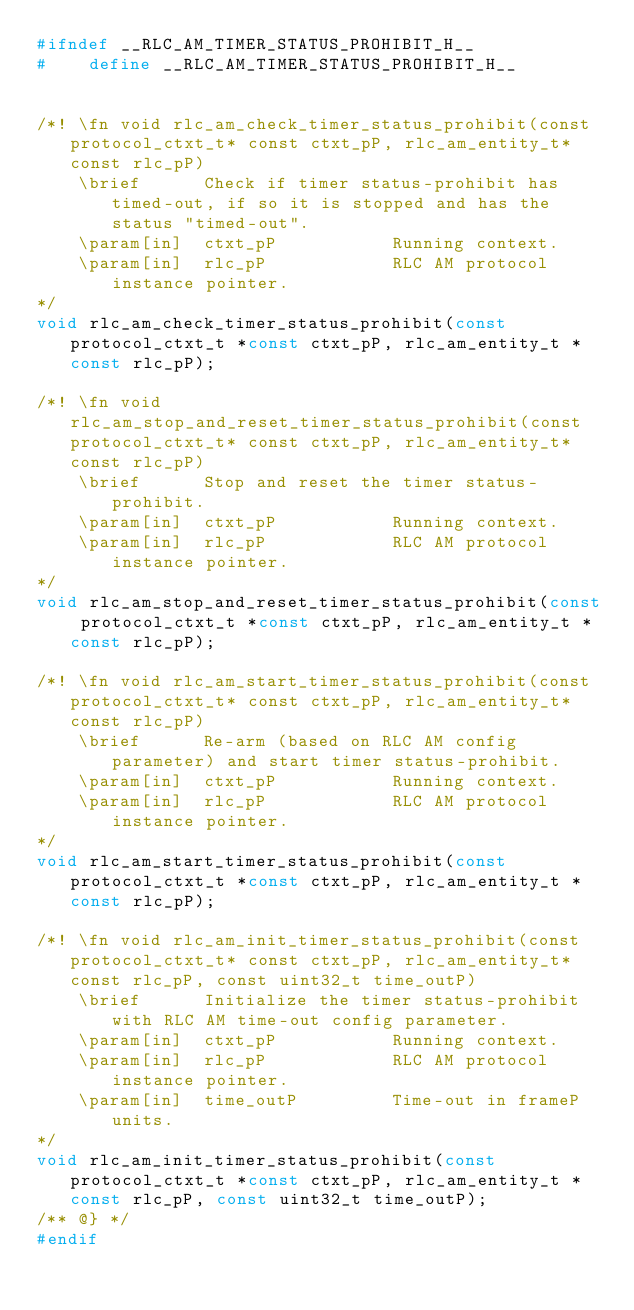Convert code to text. <code><loc_0><loc_0><loc_500><loc_500><_C_>#ifndef __RLC_AM_TIMER_STATUS_PROHIBIT_H__
#    define __RLC_AM_TIMER_STATUS_PROHIBIT_H__


/*! \fn void rlc_am_check_timer_status_prohibit(const protocol_ctxt_t* const ctxt_pP, rlc_am_entity_t* const rlc_pP)
    \brief      Check if timer status-prohibit has timed-out, if so it is stopped and has the status "timed-out".
    \param[in]  ctxt_pP           Running context.
    \param[in]  rlc_pP            RLC AM protocol instance pointer.
*/
void rlc_am_check_timer_status_prohibit(const protocol_ctxt_t *const ctxt_pP, rlc_am_entity_t *const rlc_pP);

/*! \fn void rlc_am_stop_and_reset_timer_status_prohibit(const protocol_ctxt_t* const ctxt_pP, rlc_am_entity_t* const rlc_pP)
    \brief      Stop and reset the timer status-prohibit.
    \param[in]  ctxt_pP           Running context.
    \param[in]  rlc_pP            RLC AM protocol instance pointer.
*/
void rlc_am_stop_and_reset_timer_status_prohibit(const protocol_ctxt_t *const ctxt_pP, rlc_am_entity_t *const rlc_pP);

/*! \fn void rlc_am_start_timer_status_prohibit(const protocol_ctxt_t* const ctxt_pP, rlc_am_entity_t* const rlc_pP)
    \brief      Re-arm (based on RLC AM config parameter) and start timer status-prohibit.
    \param[in]  ctxt_pP           Running context.
    \param[in]  rlc_pP            RLC AM protocol instance pointer.
*/
void rlc_am_start_timer_status_prohibit(const protocol_ctxt_t *const ctxt_pP, rlc_am_entity_t *const rlc_pP);

/*! \fn void rlc_am_init_timer_status_prohibit(const protocol_ctxt_t* const ctxt_pP, rlc_am_entity_t* const rlc_pP, const uint32_t time_outP)
    \brief      Initialize the timer status-prohibit with RLC AM time-out config parameter.
    \param[in]  ctxt_pP           Running context.
    \param[in]  rlc_pP            RLC AM protocol instance pointer.
    \param[in]  time_outP         Time-out in frameP units.
*/
void rlc_am_init_timer_status_prohibit(const protocol_ctxt_t *const ctxt_pP, rlc_am_entity_t *const rlc_pP, const uint32_t time_outP);
/** @} */
#endif
</code> 